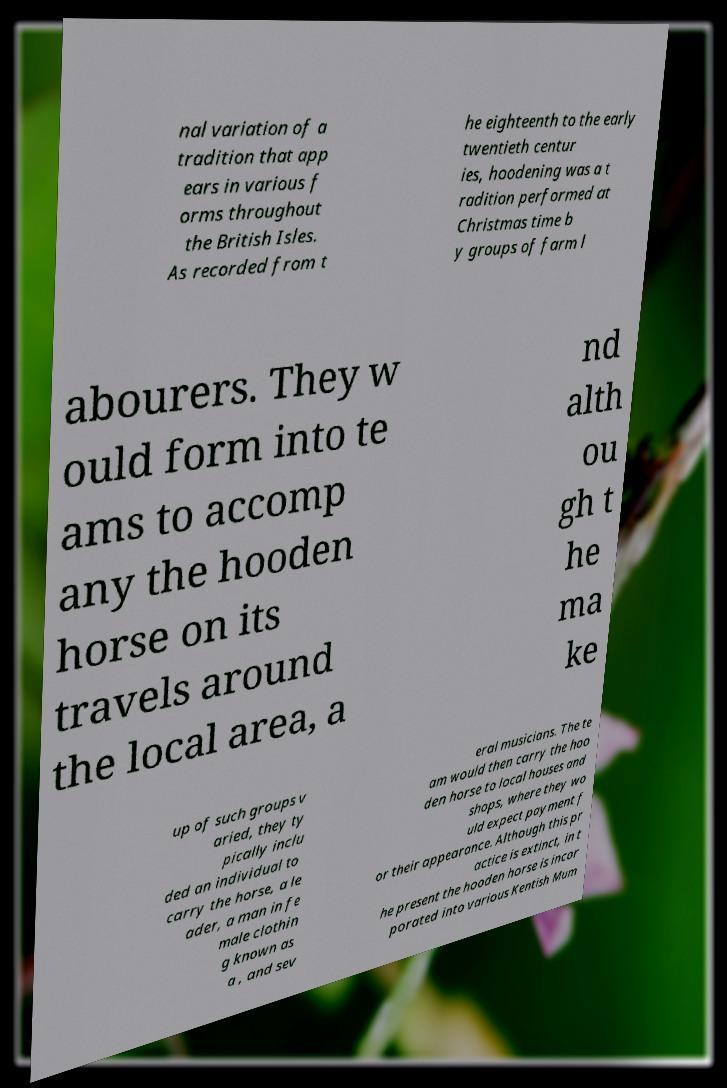What messages or text are displayed in this image? I need them in a readable, typed format. nal variation of a tradition that app ears in various f orms throughout the British Isles. As recorded from t he eighteenth to the early twentieth centur ies, hoodening was a t radition performed at Christmas time b y groups of farm l abourers. They w ould form into te ams to accomp any the hooden horse on its travels around the local area, a nd alth ou gh t he ma ke up of such groups v aried, they ty pically inclu ded an individual to carry the horse, a le ader, a man in fe male clothin g known as a , and sev eral musicians. The te am would then carry the hoo den horse to local houses and shops, where they wo uld expect payment f or their appearance. Although this pr actice is extinct, in t he present the hooden horse is incor porated into various Kentish Mum 